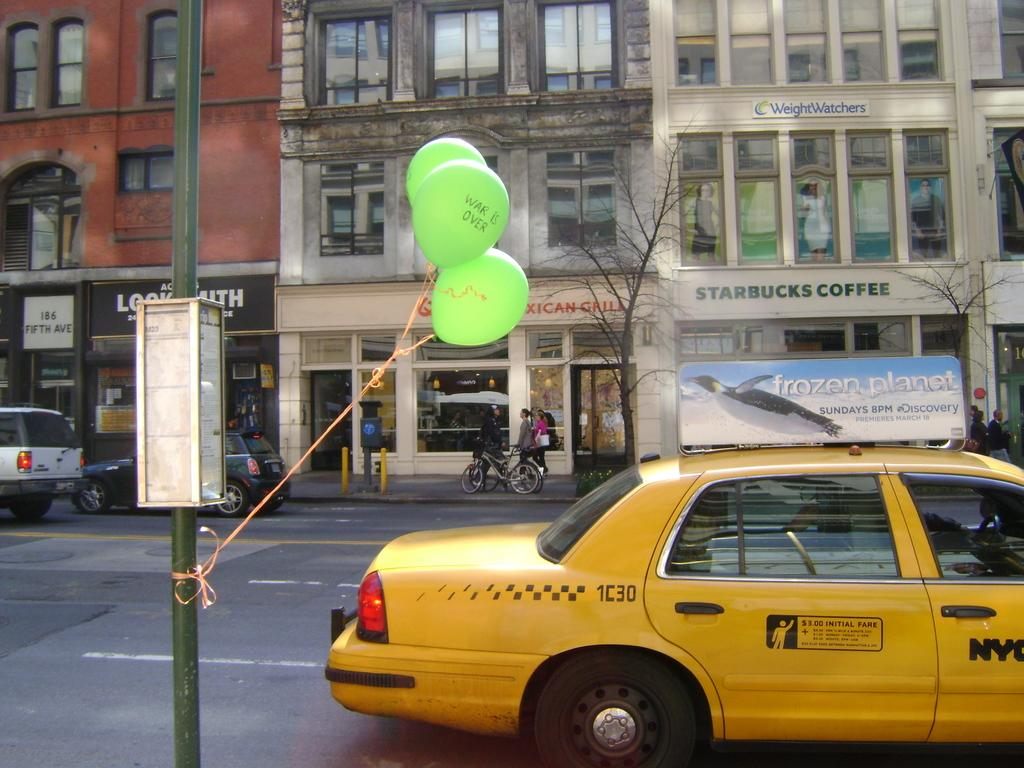<image>
Offer a succinct explanation of the picture presented. a taxi cab with the number 1C30 on it 